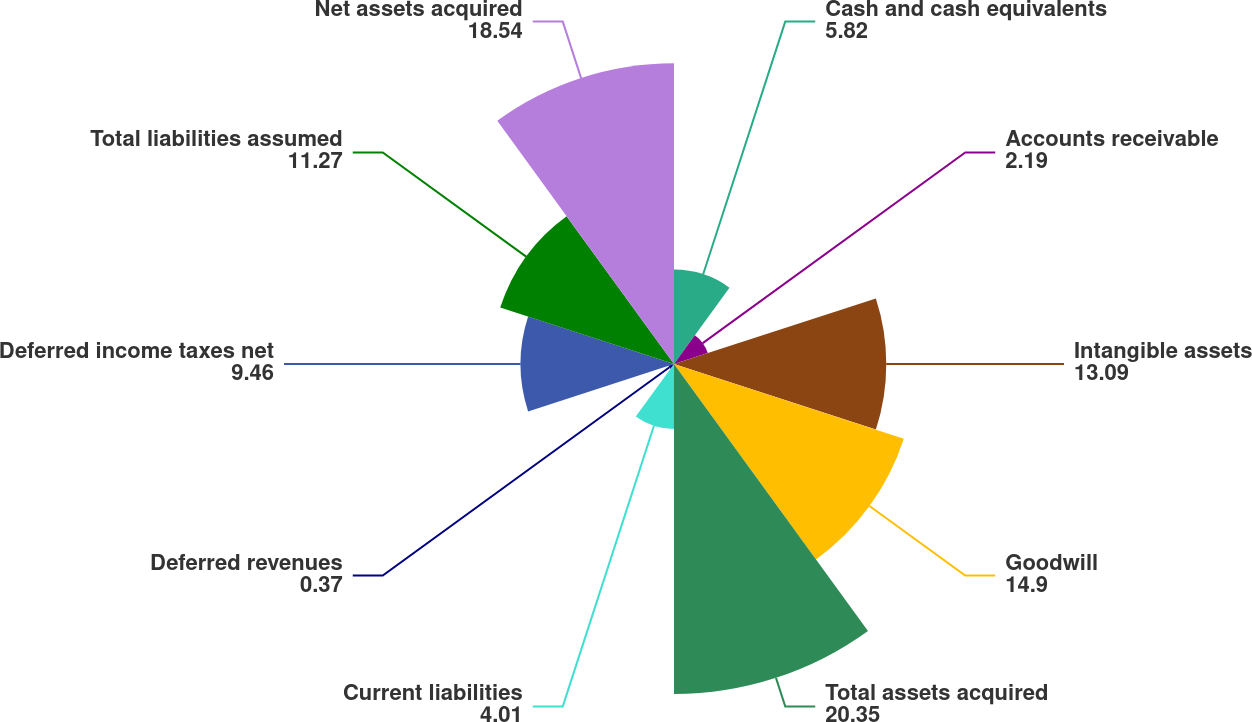Convert chart to OTSL. <chart><loc_0><loc_0><loc_500><loc_500><pie_chart><fcel>Cash and cash equivalents<fcel>Accounts receivable<fcel>Intangible assets<fcel>Goodwill<fcel>Total assets acquired<fcel>Current liabilities<fcel>Deferred revenues<fcel>Deferred income taxes net<fcel>Total liabilities assumed<fcel>Net assets acquired<nl><fcel>5.82%<fcel>2.19%<fcel>13.09%<fcel>14.9%<fcel>20.35%<fcel>4.01%<fcel>0.37%<fcel>9.46%<fcel>11.27%<fcel>18.54%<nl></chart> 